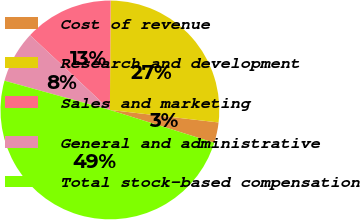Convert chart to OTSL. <chart><loc_0><loc_0><loc_500><loc_500><pie_chart><fcel>Cost of revenue<fcel>Research and development<fcel>Sales and marketing<fcel>General and administrative<fcel>Total stock-based compensation<nl><fcel>3.03%<fcel>26.72%<fcel>13.12%<fcel>7.67%<fcel>49.45%<nl></chart> 